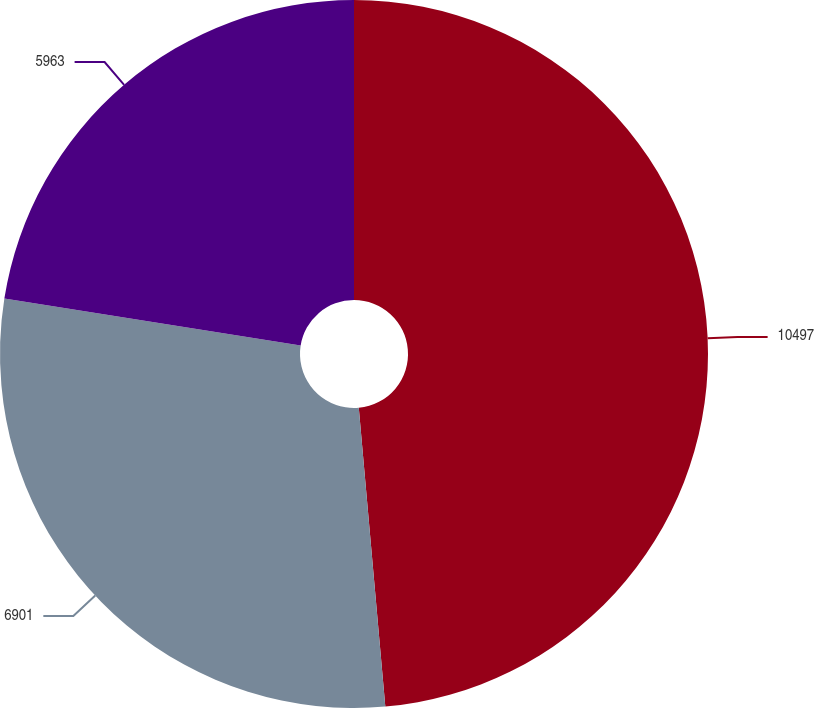Convert chart. <chart><loc_0><loc_0><loc_500><loc_500><pie_chart><fcel>10497<fcel>6901<fcel>5963<nl><fcel>48.59%<fcel>28.91%<fcel>22.5%<nl></chart> 